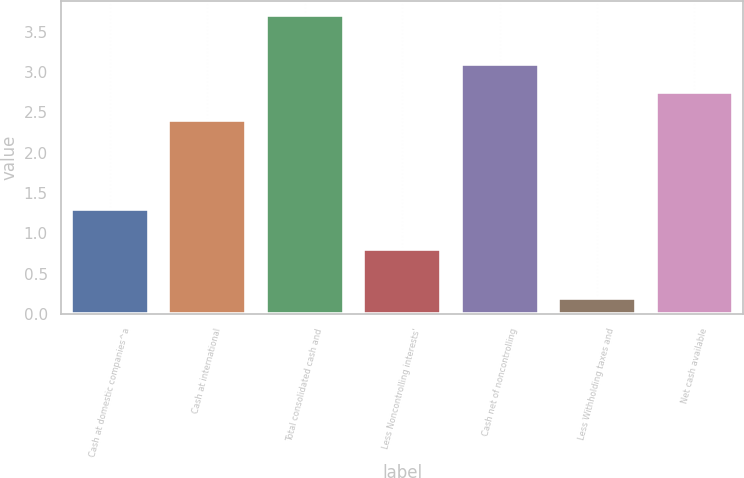Convert chart to OTSL. <chart><loc_0><loc_0><loc_500><loc_500><bar_chart><fcel>Cash at domestic companies^a<fcel>Cash at international<fcel>Total consolidated cash and<fcel>Less Noncontrolling interests'<fcel>Cash net of noncontrolling<fcel>Less Withholding taxes and<fcel>Net cash available<nl><fcel>1.3<fcel>2.4<fcel>3.7<fcel>0.8<fcel>3.1<fcel>0.2<fcel>2.75<nl></chart> 